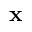<formula> <loc_0><loc_0><loc_500><loc_500>x</formula> 